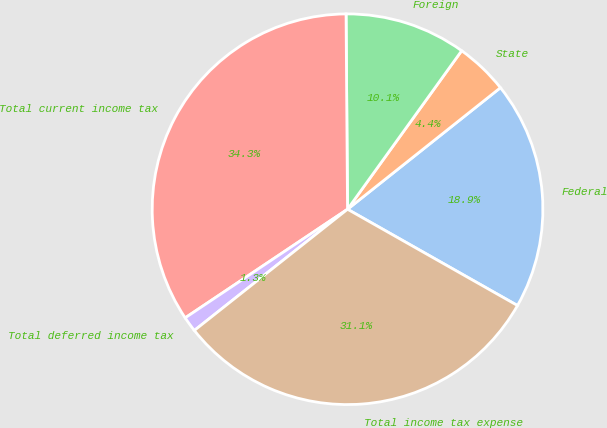<chart> <loc_0><loc_0><loc_500><loc_500><pie_chart><fcel>Federal<fcel>State<fcel>Foreign<fcel>Total current income tax<fcel>Total deferred income tax<fcel>Total income tax expense<nl><fcel>18.89%<fcel>4.38%<fcel>10.05%<fcel>34.26%<fcel>1.27%<fcel>31.14%<nl></chart> 